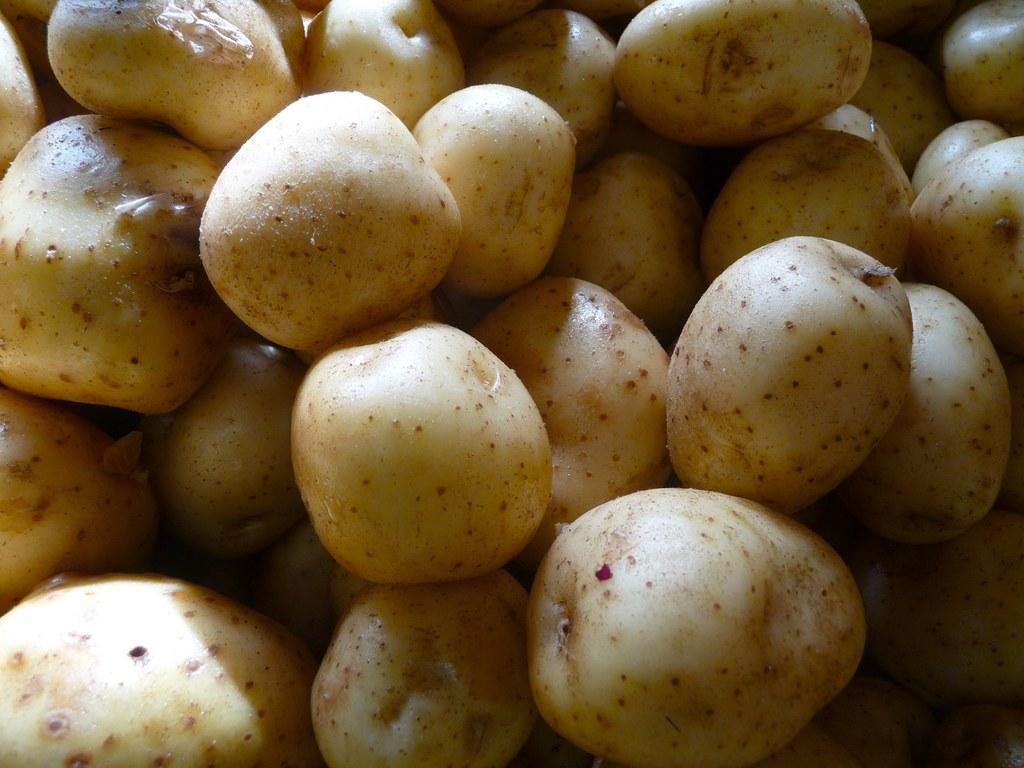What is the main subject of the image? The main subject of the image is many potatoes. Where are the potatoes located in the image? The potatoes are in the front of the image. What type of birthday celebration is happening with the potatoes in the image? There is no indication of a birthday celebration in the image; it simply features many potatoes. Can you tell me how many sheep are in the flock with the potatoes in the image? There are no sheep or any other animals present in the image; it only contains potatoes. 